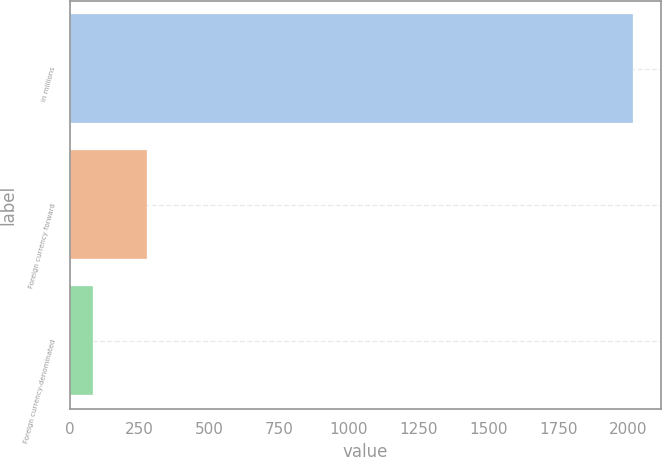Convert chart to OTSL. <chart><loc_0><loc_0><loc_500><loc_500><bar_chart><fcel>in millions<fcel>Foreign currency forward<fcel>Foreign currency-denominated<nl><fcel>2016<fcel>278.1<fcel>85<nl></chart> 